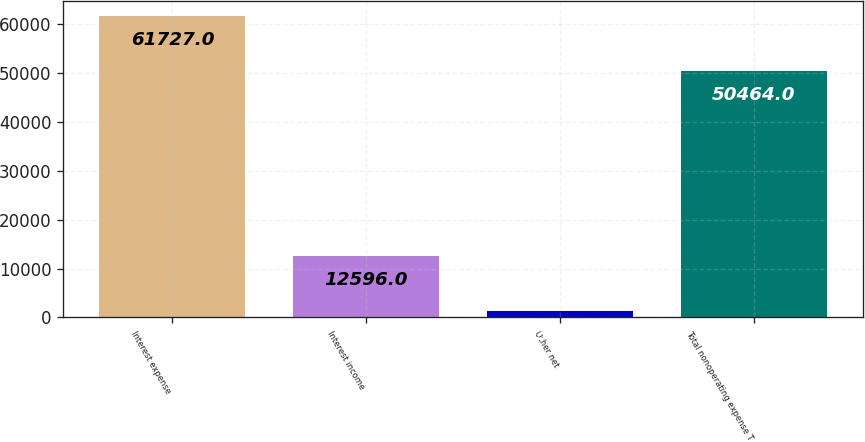<chart> <loc_0><loc_0><loc_500><loc_500><bar_chart><fcel>Interest expense<fcel>Interest income<fcel>Other net<fcel>Total nonoperating expense T<nl><fcel>61727<fcel>12596<fcel>1333<fcel>50464<nl></chart> 